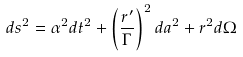Convert formula to latex. <formula><loc_0><loc_0><loc_500><loc_500>d s ^ { 2 } = \alpha ^ { 2 } d t ^ { 2 } + \left ( \frac { r ^ { \prime } } { \Gamma } \right ) ^ { 2 } d a ^ { 2 } + r ^ { 2 } d \Omega</formula> 